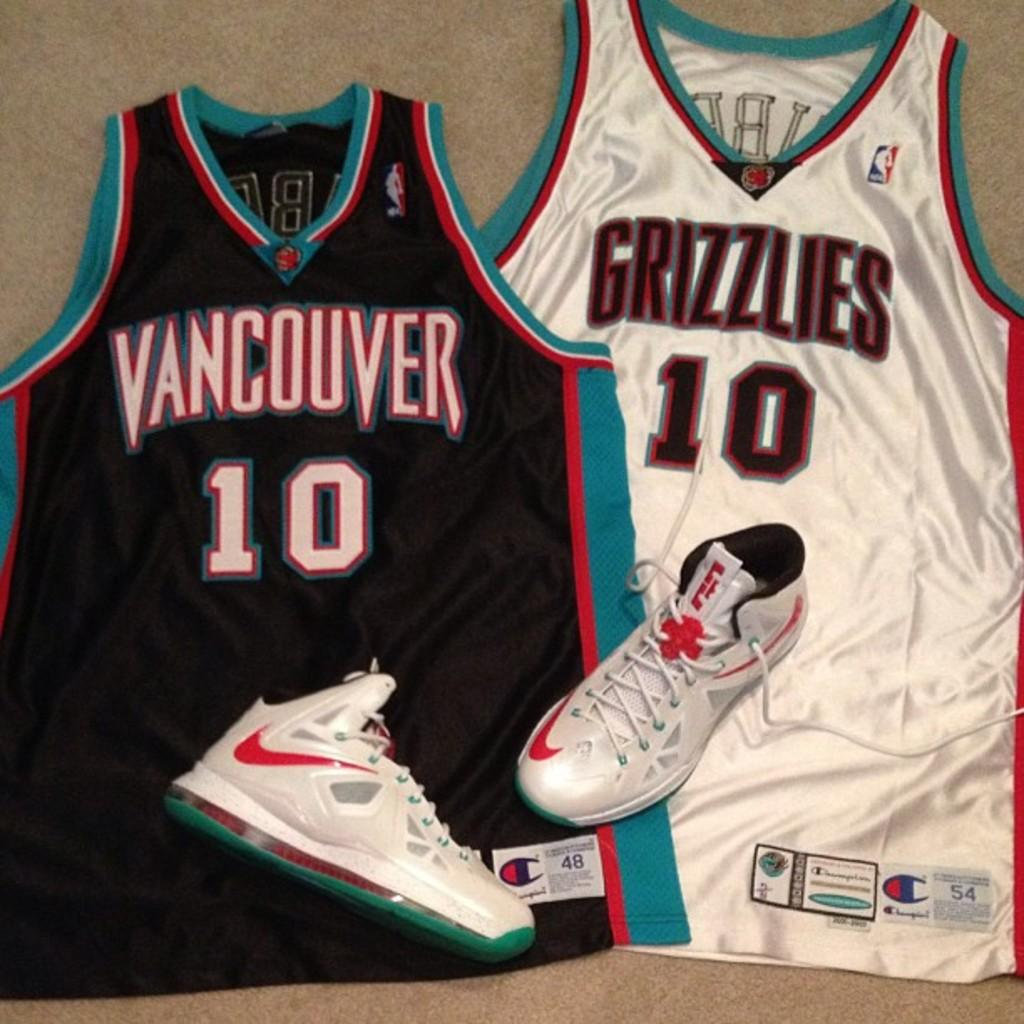<image>
Summarize the visual content of the image. A casually tossed pair of sneakers sit on top of a Grizzlies shirt and a Vancouver shirt. 